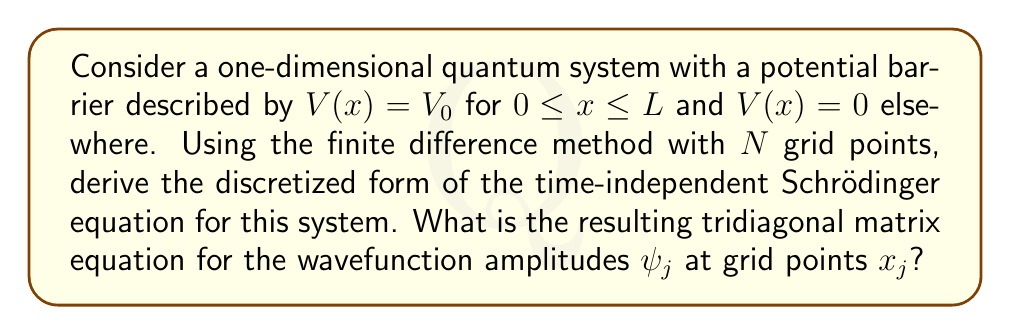Solve this math problem. Let's approach this step-by-step:

1) The time-independent Schrödinger equation in one dimension is:

   $$-\frac{\hbar^2}{2m}\frac{d^2\psi}{dx^2} + V(x)\psi = E\psi$$

2) To apply the finite difference method, we discretize the x-axis into N points with spacing $\Delta x = L/(N-1)$.

3) The second derivative can be approximated using the central difference formula:

   $$\frac{d^2\psi}{dx^2} \approx \frac{\psi_{j+1} - 2\psi_j + \psi_{j-1}}{(\Delta x)^2}$$

4) Substituting this into the Schrödinger equation:

   $$-\frac{\hbar^2}{2m}\frac{\psi_{j+1} - 2\psi_j + \psi_{j-1}}{(\Delta x)^2} + V_j\psi_j = E\psi_j$$

5) Rearranging terms:

   $$\frac{\hbar^2}{2m(\Delta x)^2}(\psi_{j+1} - 2\psi_j + \psi_{j-1}) + (V_j - E)\psi_j = 0$$

6) Let's define $\alpha = \frac{\hbar^2}{2m(\Delta x)^2}$. Then we have:

   $$\alpha(\psi_{j+1} - 2\psi_j + \psi_{j-1}) + (V_j - E)\psi_j = 0$$

7) Rearranging again:

   $$-\alpha\psi_{j-1} + (2\alpha + V_j - E)\psi_j - \alpha\psi_{j+1} = 0$$

8) This forms a tridiagonal system of equations for $j = 1, 2, ..., N$, which can be written in matrix form as:

   $$\begin{pmatrix}
   2\alpha+V_1-E & -\alpha & 0 & \cdots & 0 \\
   -\alpha & 2\alpha+V_2-E & -\alpha & \cdots & 0 \\
   0 & -\alpha & 2\alpha+V_3-E & \cdots & 0 \\
   \vdots & \vdots & \vdots & \ddots & \vdots \\
   0 & 0 & 0 & \cdots & 2\alpha+V_N-E
   \end{pmatrix}
   \begin{pmatrix}
   \psi_1 \\ \psi_2 \\ \psi_3 \\ \vdots \\ \psi_N
   \end{pmatrix}
   = \begin{pmatrix}
   0 \\ 0 \\ 0 \\ \vdots \\ 0
   \end{pmatrix}$$

This is the final tridiagonal matrix equation for the wavefunction amplitudes.
Answer: $-\alpha\psi_{j-1} + (2\alpha + V_j - E)\psi_j - \alpha\psi_{j+1} = 0$, where $\alpha = \frac{\hbar^2}{2m(\Delta x)^2}$ 